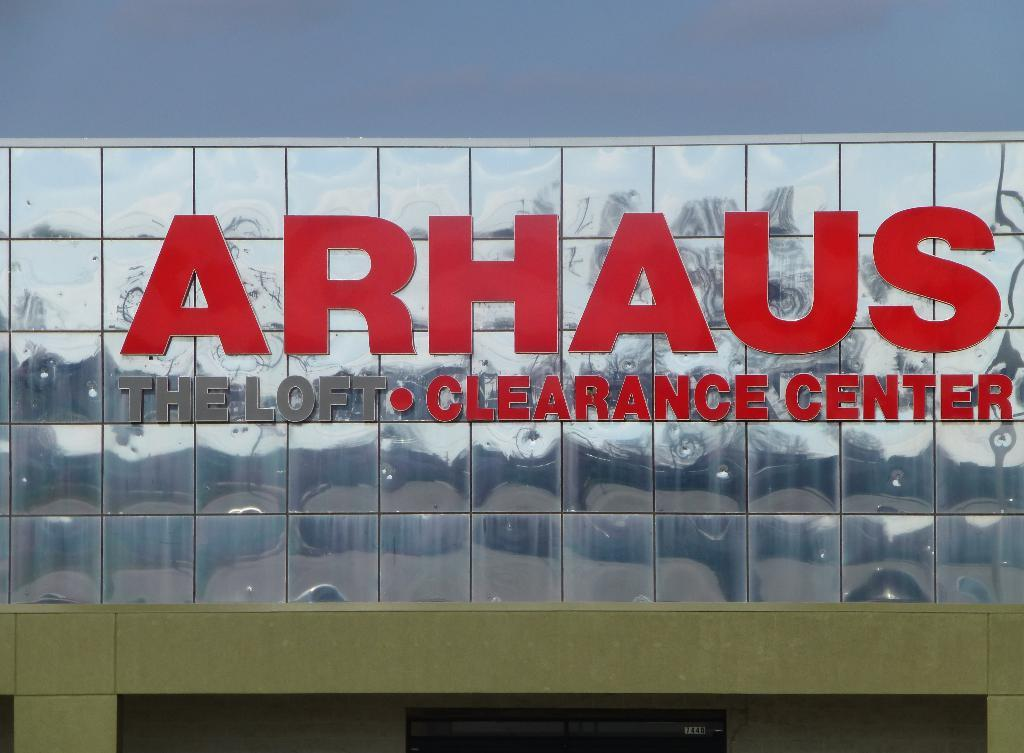Provide a one-sentence caption for the provided image. A sign for a store name Arhaus Clearance Center. 